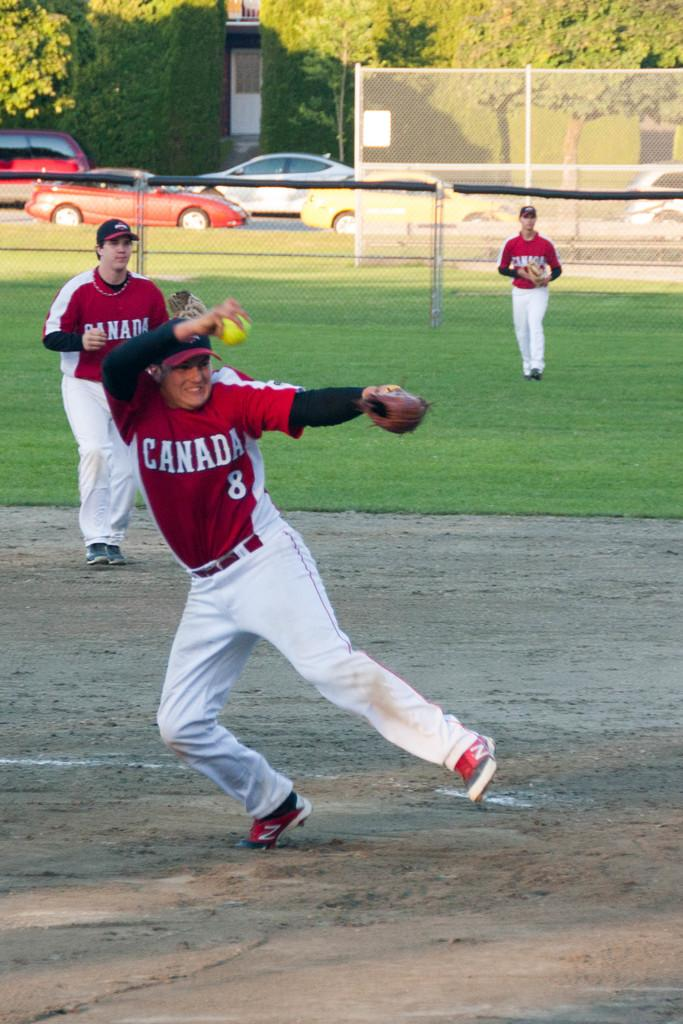What activity are the three persons in the image engaged in? The three persons in the image are playing baseball. What is visible at the bottom of the image? There is ground at the bottom of the image. What type of vegetation can be seen in the background of the image? There is green grass in the background of the image. What can be seen on the road in the background of the image? There are cars on the road in the background of the image. What else is present along the road in the background of the image? There are trees along the road in the background of the image. What color is the rifle that one of the baseball players is holding in the image? There is no rifle present in the image; the three persons are playing baseball with a bat and a ball. 